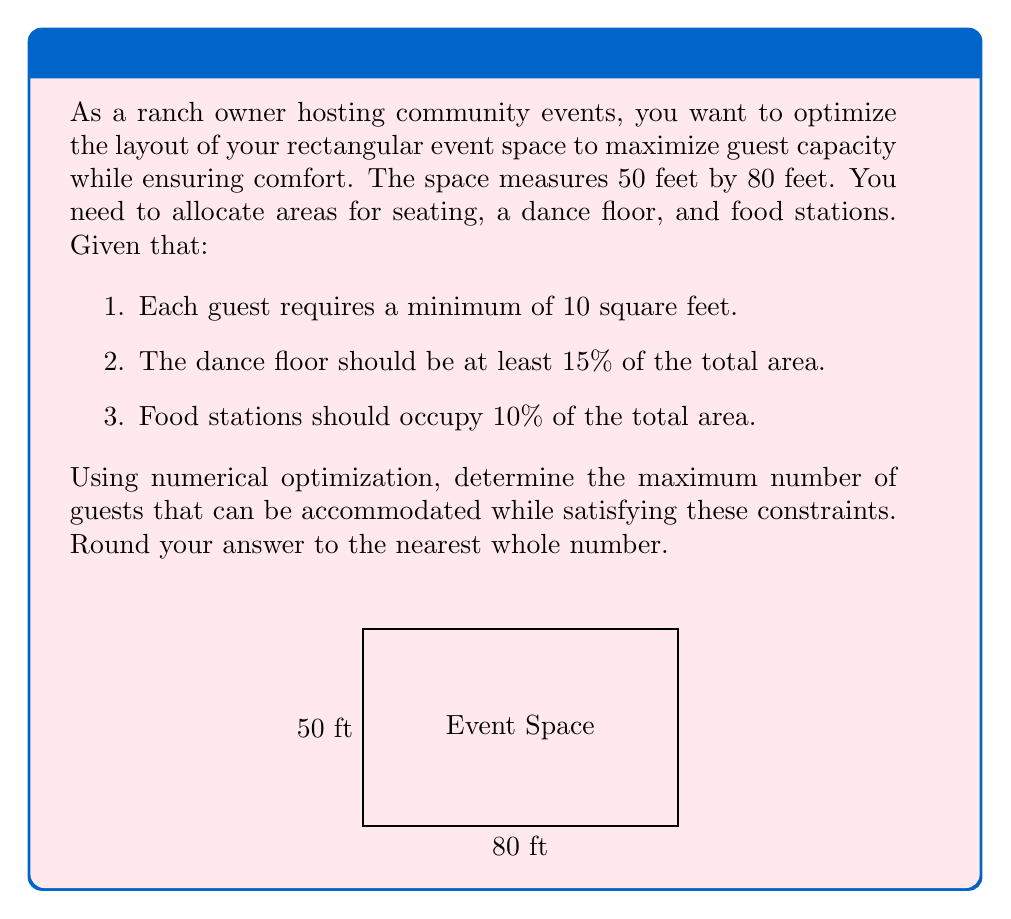Help me with this question. Let's approach this step-by-step using numerical optimization:

1) First, calculate the total area of the event space:
   $$ \text{Total Area} = 50 \text{ ft} \times 80 \text{ ft} = 4000 \text{ sq ft} $$

2) Calculate the minimum areas for dance floor and food stations:
   $$ \text{Dance Floor (min)} = 15\% \text{ of } 4000 = 600 \text{ sq ft} $$
   $$ \text{Food Stations} = 10\% \text{ of } 4000 = 400 \text{ sq ft} $$

3) Remaining area for guest seating:
   $$ \text{Seating Area} = 4000 - 600 - 400 = 3000 \text{ sq ft} $$

4) Given that each guest requires 10 sq ft, we can calculate the maximum number of guests:
   $$ \text{Max Guests} = \frac{\text{Seating Area}}{\text{Area per Guest}} = \frac{3000}{10} = 300 $$

5) Verify constraints:
   - Dance floor: $600 \text{ sq ft} \geq 15\% \text{ of } 4000 \text{ sq ft}$ (Satisfied)
   - Food stations: $400 \text{ sq ft} = 10\% \text{ of } 4000 \text{ sq ft}$ (Satisfied)
   - Guest area: $3000 \text{ sq ft} = 10 \text{ sq ft} \times 300 \text{ guests}$ (Satisfied)

Therefore, the maximum number of guests that can be accommodated while satisfying all constraints is 300.
Answer: 300 guests 